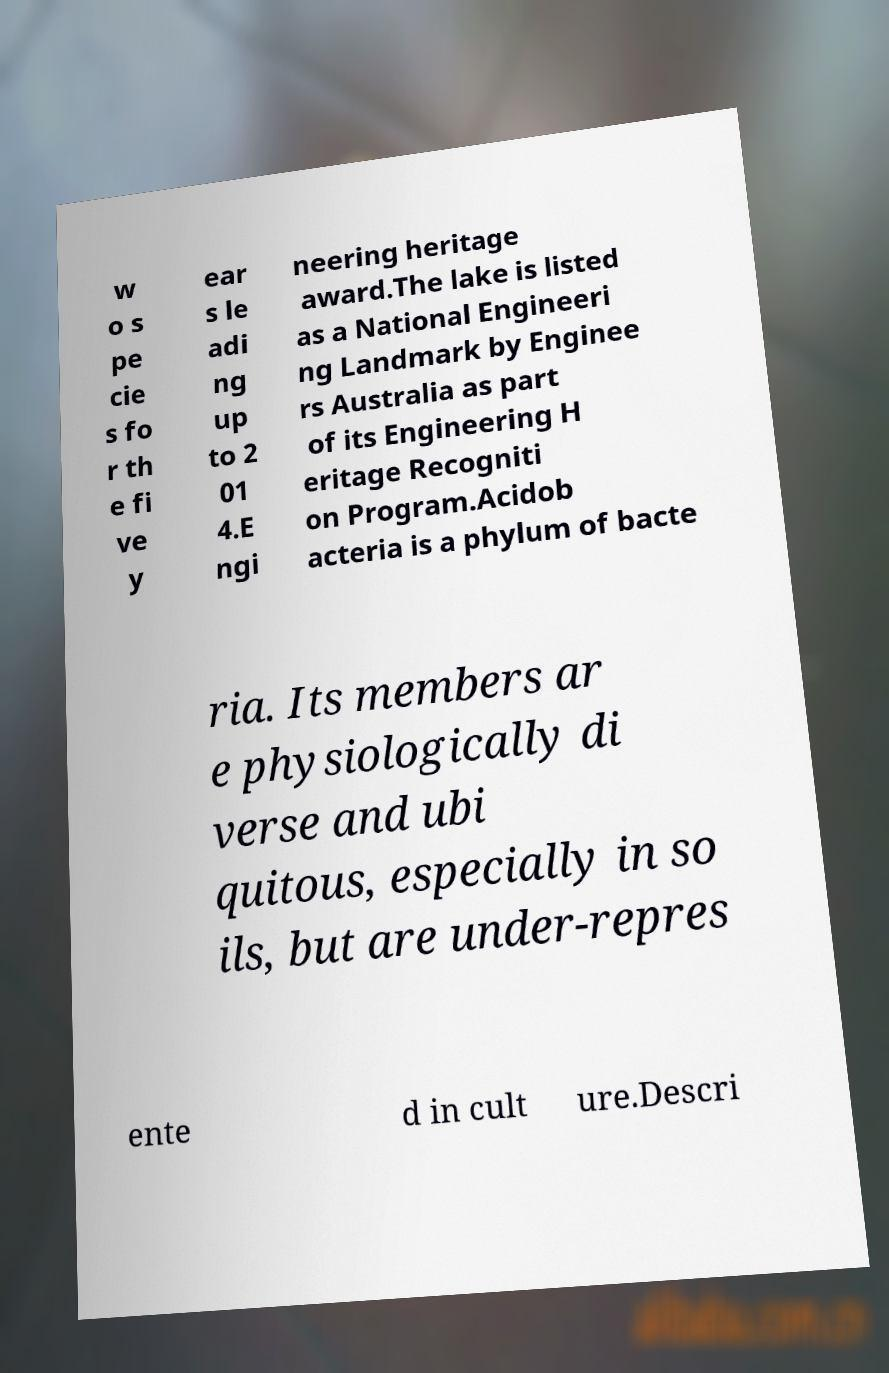Please identify and transcribe the text found in this image. w o s pe cie s fo r th e fi ve y ear s le adi ng up to 2 01 4.E ngi neering heritage award.The lake is listed as a National Engineeri ng Landmark by Enginee rs Australia as part of its Engineering H eritage Recogniti on Program.Acidob acteria is a phylum of bacte ria. Its members ar e physiologically di verse and ubi quitous, especially in so ils, but are under-repres ente d in cult ure.Descri 